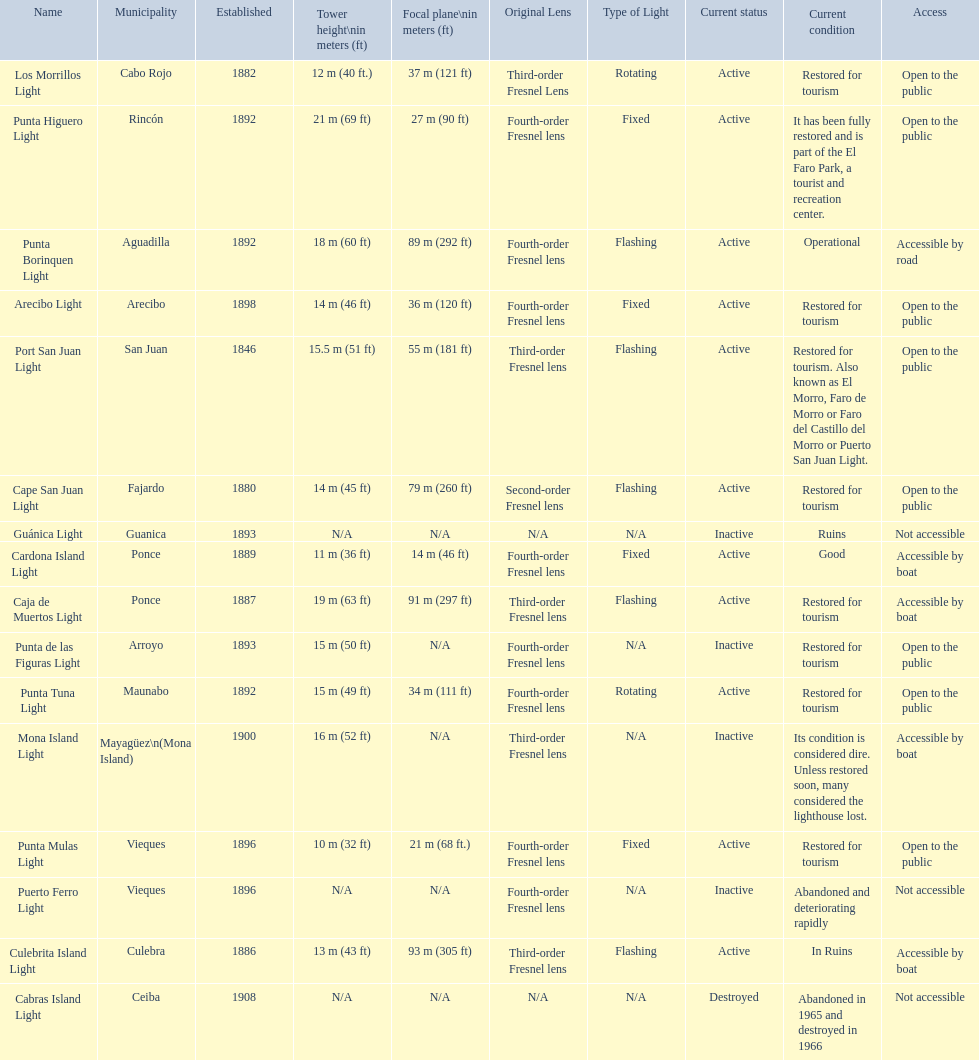Which municipality was the first to be established? San Juan. 